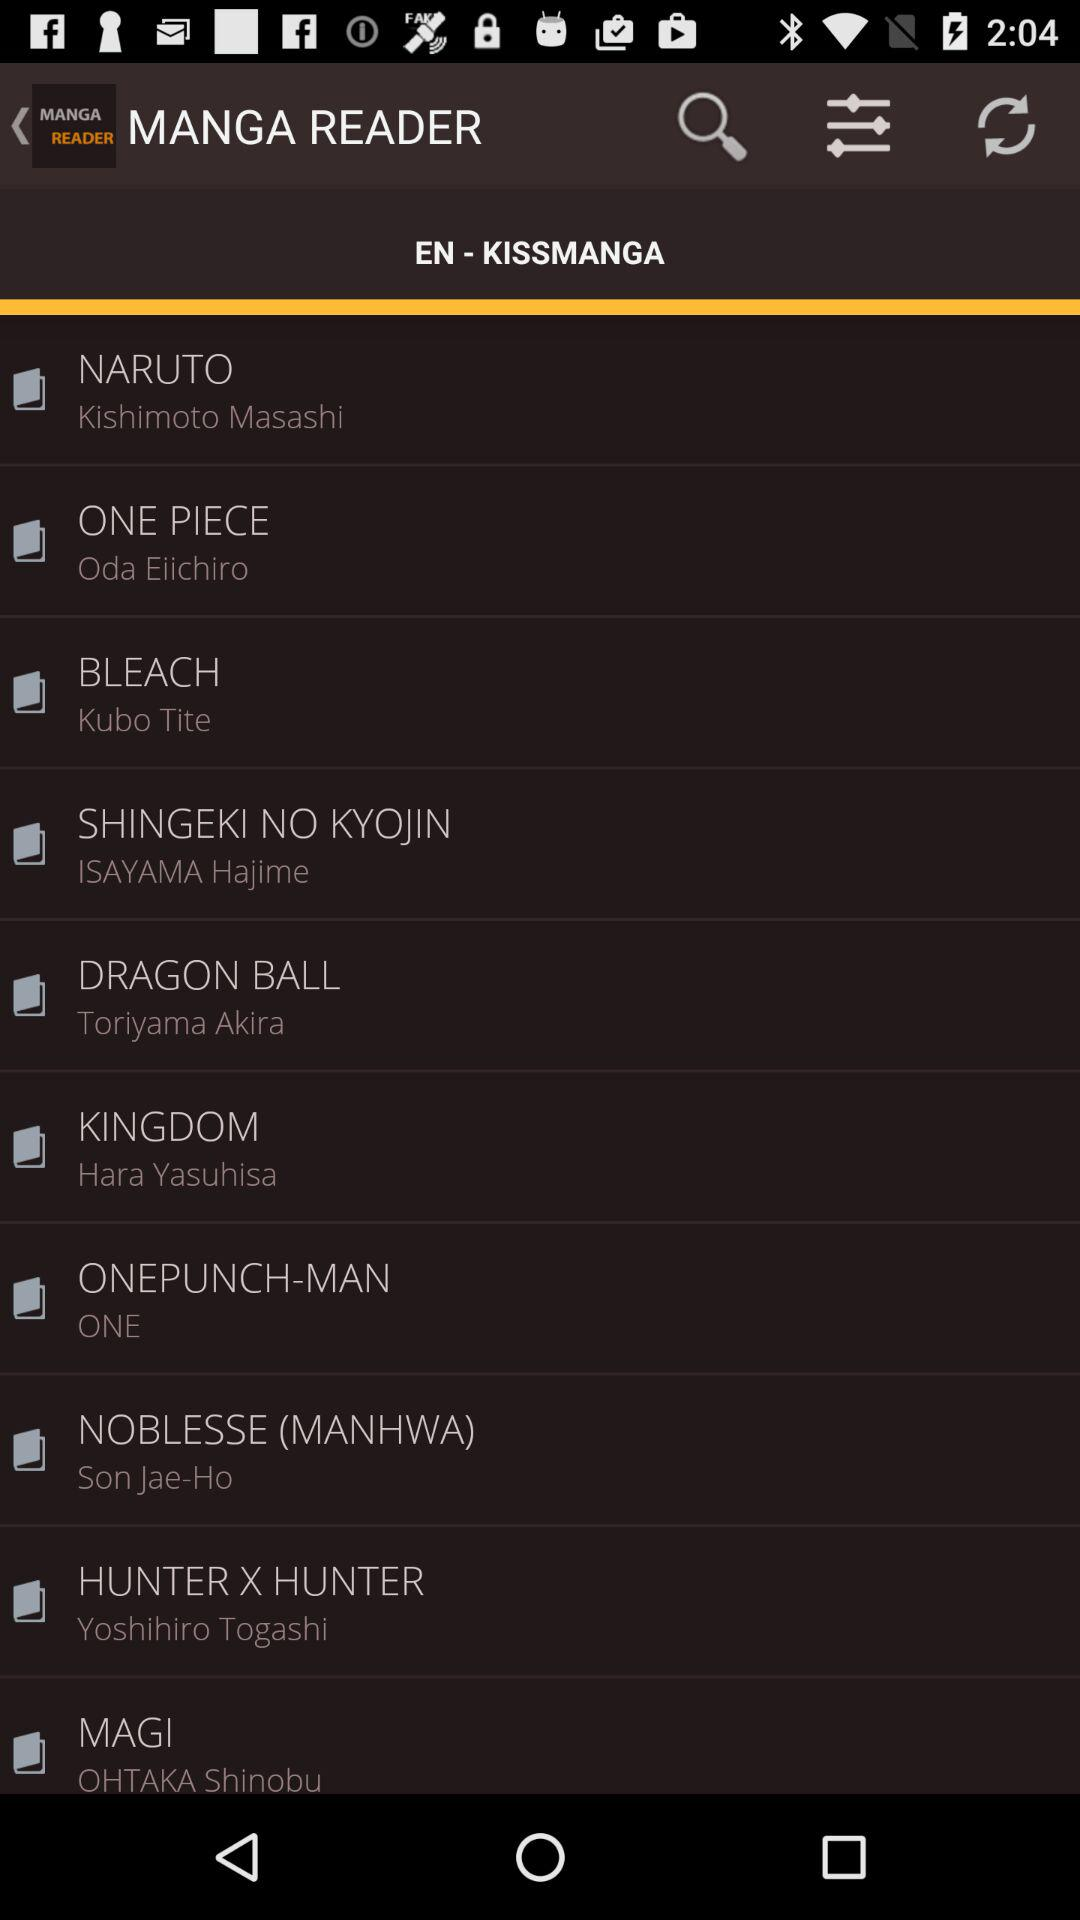What series was written by Kubo Tite? The series that was written by Kubo Tite is "BLEACH". 